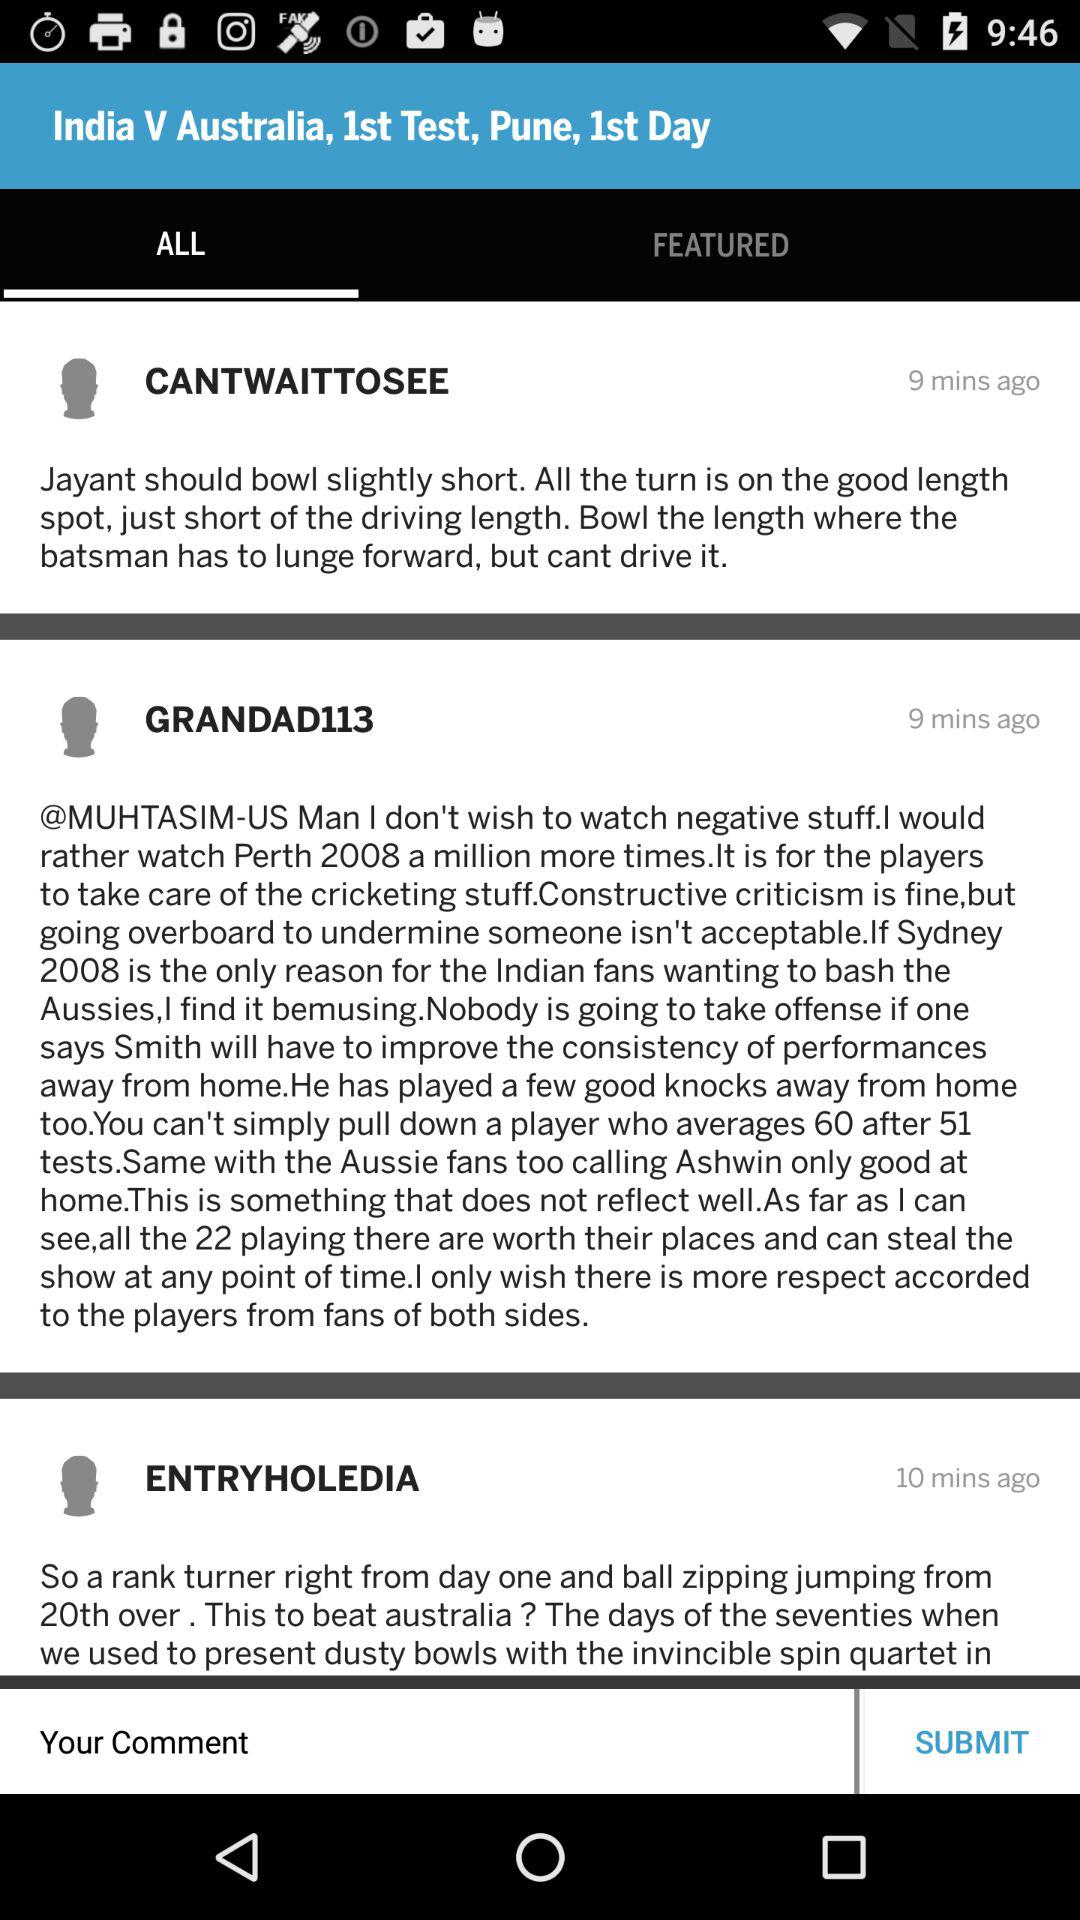Which tab is selected? The selected tab is "ALL". 